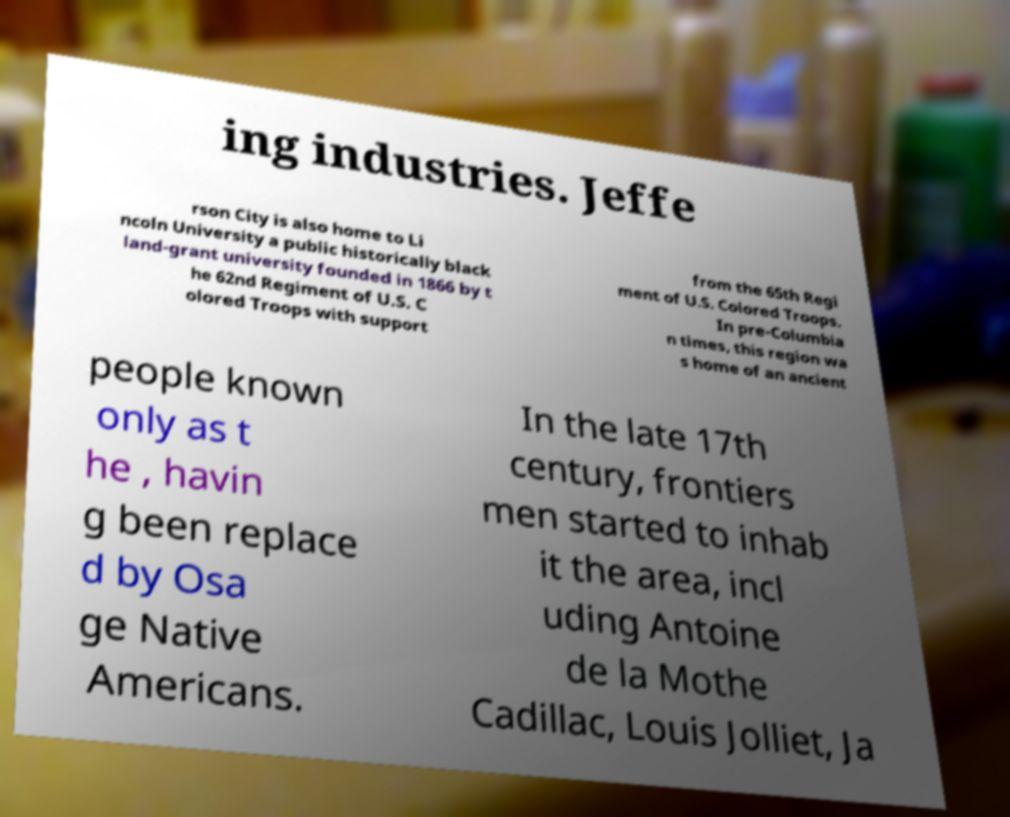Can you accurately transcribe the text from the provided image for me? ing industries. Jeffe rson City is also home to Li ncoln University a public historically black land-grant university founded in 1866 by t he 62nd Regiment of U.S. C olored Troops with support from the 65th Regi ment of U.S. Colored Troops. In pre-Columbia n times, this region wa s home of an ancient people known only as t he , havin g been replace d by Osa ge Native Americans. In the late 17th century, frontiers men started to inhab it the area, incl uding Antoine de la Mothe Cadillac, Louis Jolliet, Ja 